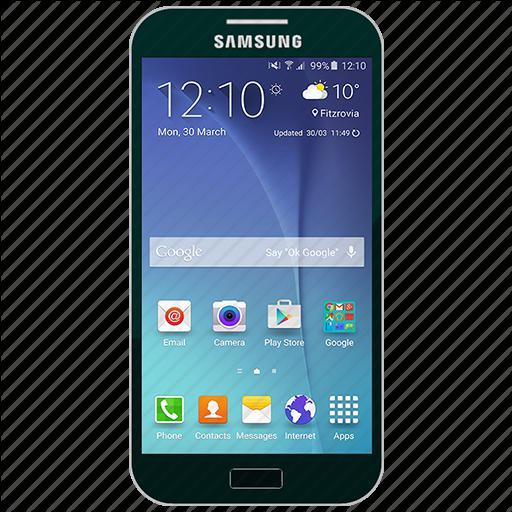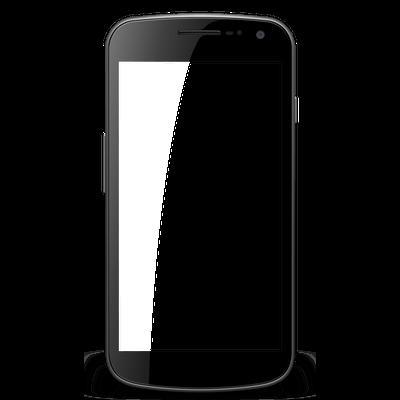The first image is the image on the left, the second image is the image on the right. Evaluate the accuracy of this statement regarding the images: "One of the phones is turned off, with a blank screen.". Is it true? Answer yes or no. Yes. The first image is the image on the left, the second image is the image on the right. Given the left and right images, does the statement "The right image contains one smart phone with a black screen." hold true? Answer yes or no. Yes. 